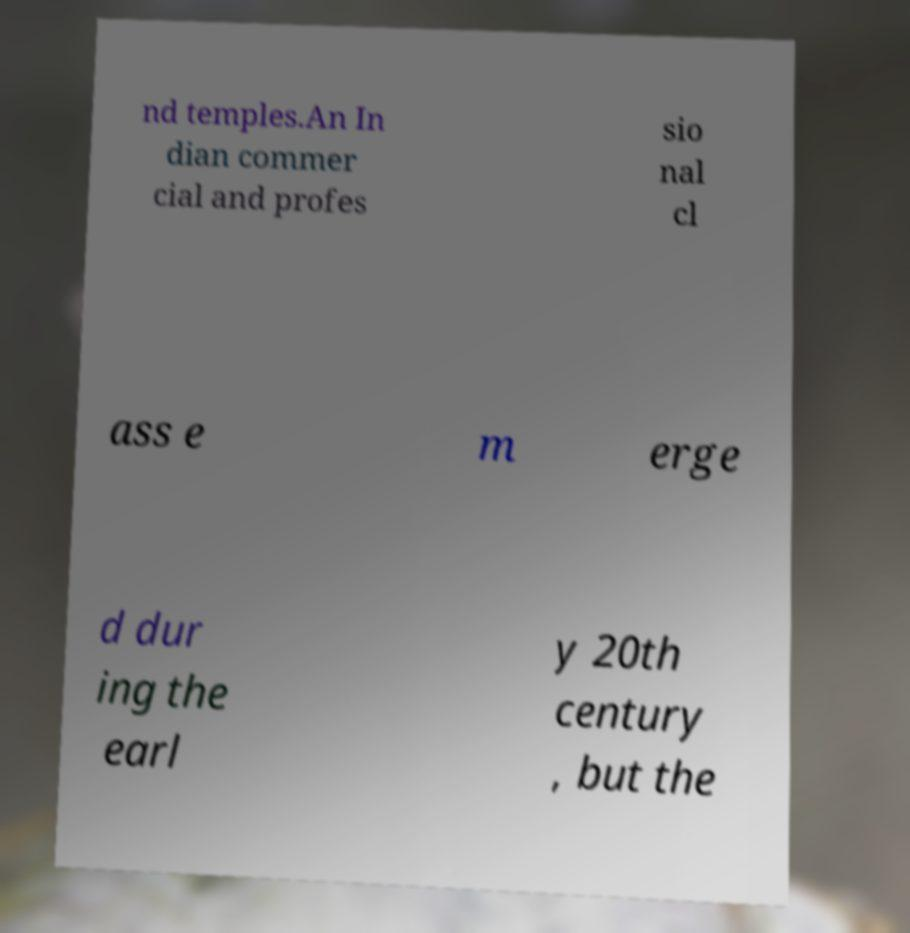I need the written content from this picture converted into text. Can you do that? nd temples.An In dian commer cial and profes sio nal cl ass e m erge d dur ing the earl y 20th century , but the 